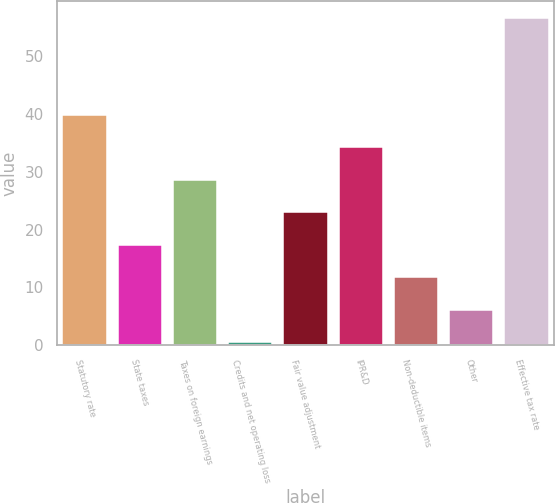<chart> <loc_0><loc_0><loc_500><loc_500><bar_chart><fcel>Statutory rate<fcel>State taxes<fcel>Taxes on foreign earnings<fcel>Credits and net operating loss<fcel>Fair value adjustment<fcel>IPR&D<fcel>Non-deductible items<fcel>Other<fcel>Effective tax rate<nl><fcel>39.8<fcel>17.4<fcel>28.6<fcel>0.6<fcel>23<fcel>34.2<fcel>11.8<fcel>6.2<fcel>56.6<nl></chart> 